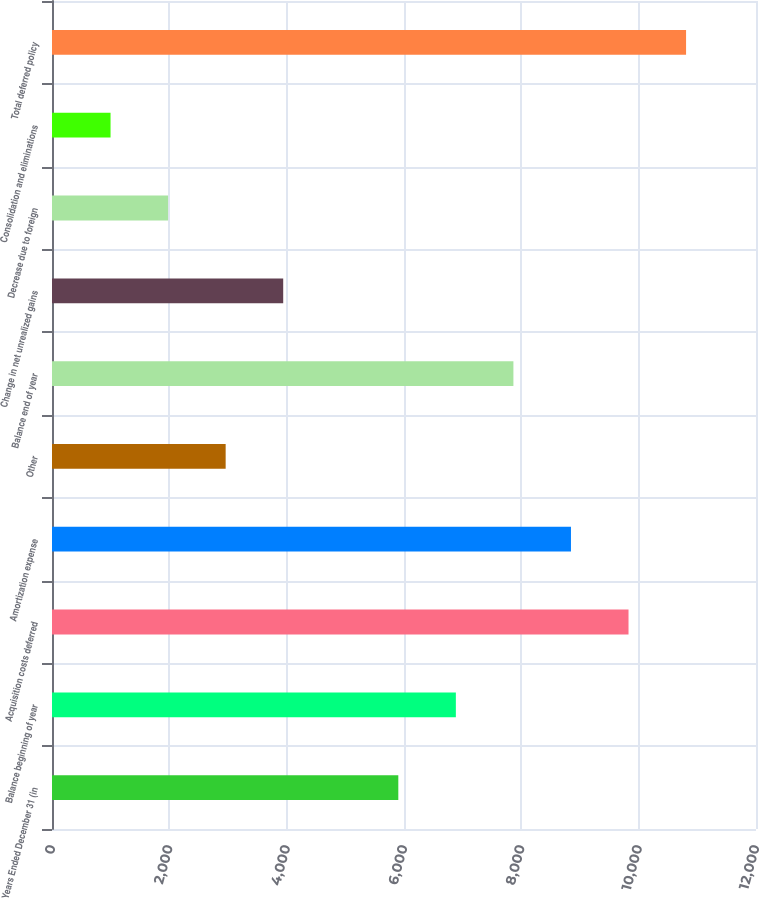Convert chart to OTSL. <chart><loc_0><loc_0><loc_500><loc_500><bar_chart><fcel>Years Ended December 31 (in<fcel>Balance beginning of year<fcel>Acquisition costs deferred<fcel>Amortization expense<fcel>Other<fcel>Balance end of year<fcel>Change in net unrealized gains<fcel>Decrease due to foreign<fcel>Consolidation and eliminations<fcel>Total deferred policy<nl><fcel>5903<fcel>6884<fcel>9827<fcel>8846<fcel>2960<fcel>7865<fcel>3941<fcel>1979<fcel>998<fcel>10808<nl></chart> 